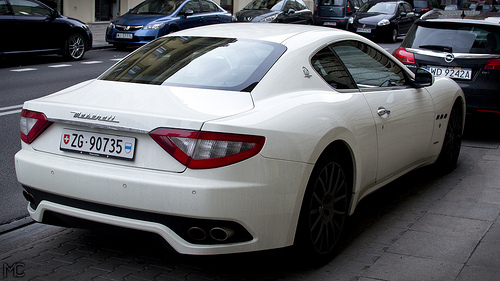<image>
Is the car in front of the car? Yes. The car is positioned in front of the car, appearing closer to the camera viewpoint. 